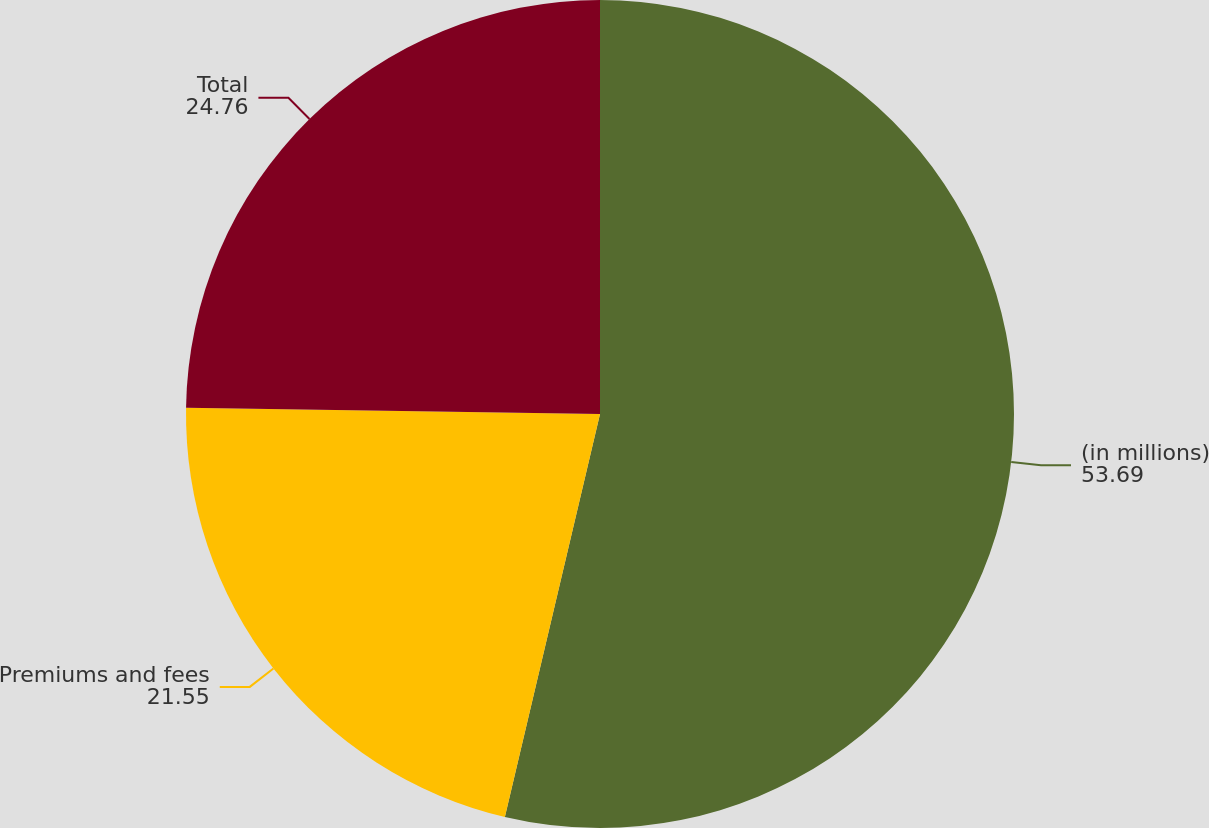<chart> <loc_0><loc_0><loc_500><loc_500><pie_chart><fcel>(in millions)<fcel>Premiums and fees<fcel>Total<nl><fcel>53.69%<fcel>21.55%<fcel>24.76%<nl></chart> 